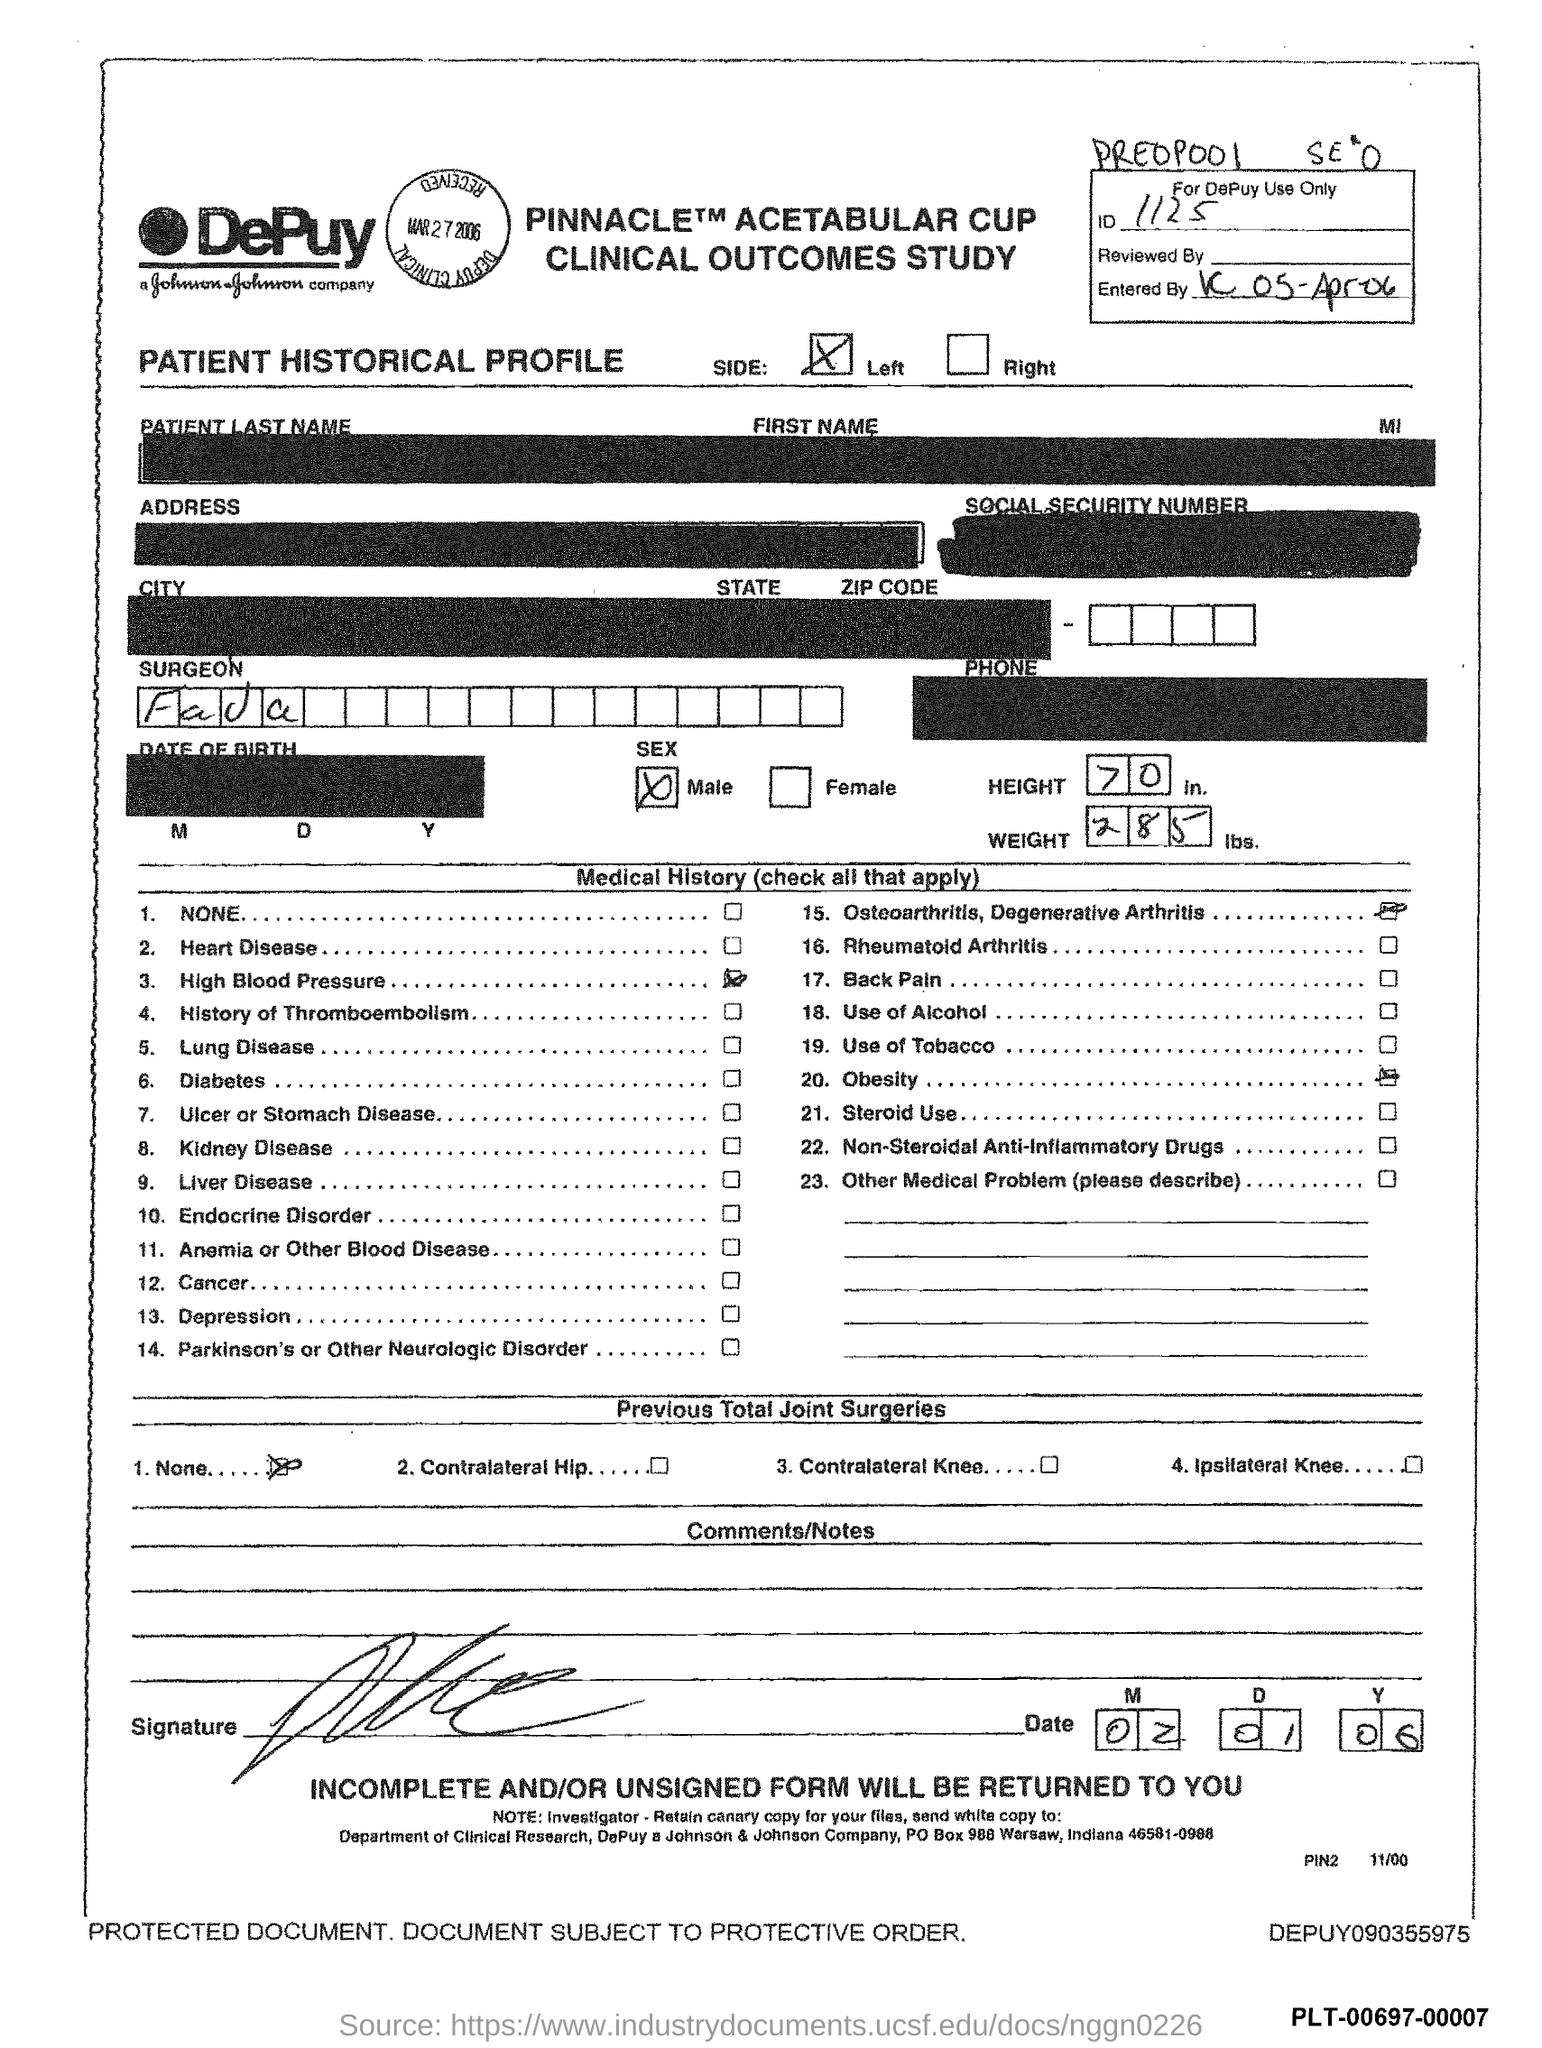What is the ID?
Provide a succinct answer. 1125. What is the Height?
Offer a very short reply. 70 in. What is the weight?
Ensure brevity in your answer.  285 lbs. What is the Date?
Your response must be concise. 02 01 06. 